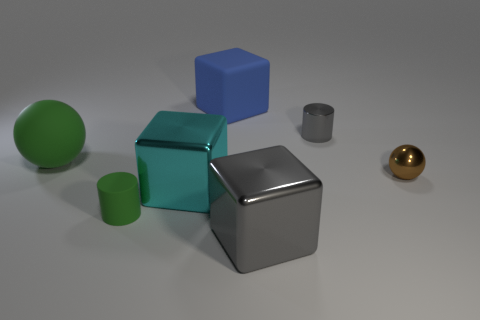Is the color of the matte ball the same as the small matte cylinder?
Your answer should be very brief. Yes. What number of things are to the left of the gray cylinder and behind the large gray metallic block?
Ensure brevity in your answer.  4. How many things are blocks or big metal objects on the left side of the large gray metallic object?
Your answer should be compact. 3. What is the shape of the thing that is the same color as the rubber sphere?
Offer a very short reply. Cylinder. What is the color of the small thing left of the small gray thing?
Ensure brevity in your answer.  Green. How many objects are spheres on the right side of the green matte cylinder or big metal objects?
Your response must be concise. 3. There is a matte block that is the same size as the cyan metal block; what is its color?
Give a very brief answer. Blue. Is the number of large gray cubes behind the big cyan shiny thing greater than the number of gray cubes?
Give a very brief answer. No. What is the material of the large object that is both behind the large cyan cube and right of the tiny green cylinder?
Your answer should be very brief. Rubber. Is the color of the large cube in front of the small green matte cylinder the same as the small cylinder that is to the right of the matte block?
Your answer should be compact. Yes. 